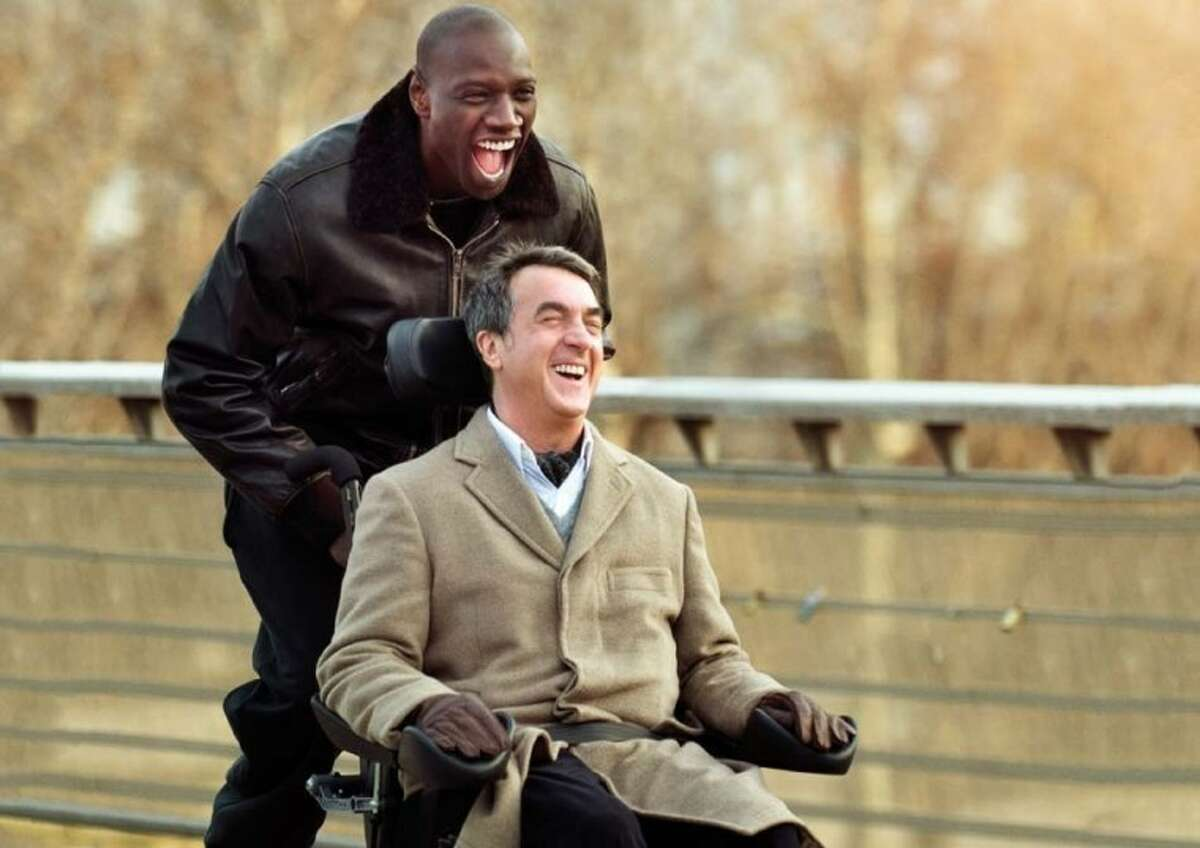Can you describe the main features of this image for me? The image captures a moment of pure joy between two individuals. One is seated in a modern wheelchair, suggesting that he has limited mobility. He's dressed warmly in a beige coat, suggesting it might be a cool day. His face radiates happiness, accentuated by a wide, genuine smile that seems to be reflecting the laughter of the person standing behind him. This second person, standing upright with a wide stance, wears a black leather jacket and a warm, joyful expression that includes a broad, contagious smile. The background features blurred trees, implying a natural or park setting, and they appear to be on a bridge, which adds a sense of openness and expansiveness to this shared moment of happiness. 